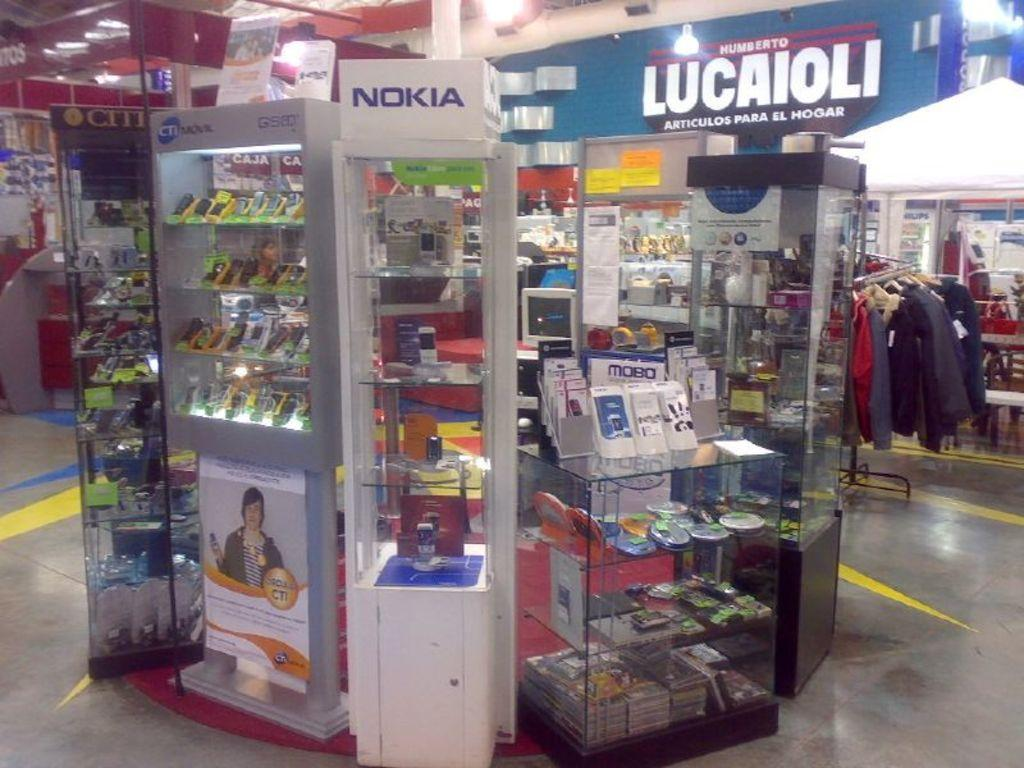<image>
Share a concise interpretation of the image provided. A kiosk in a mall selling many things with a sign reading Lucaioli behind it. 